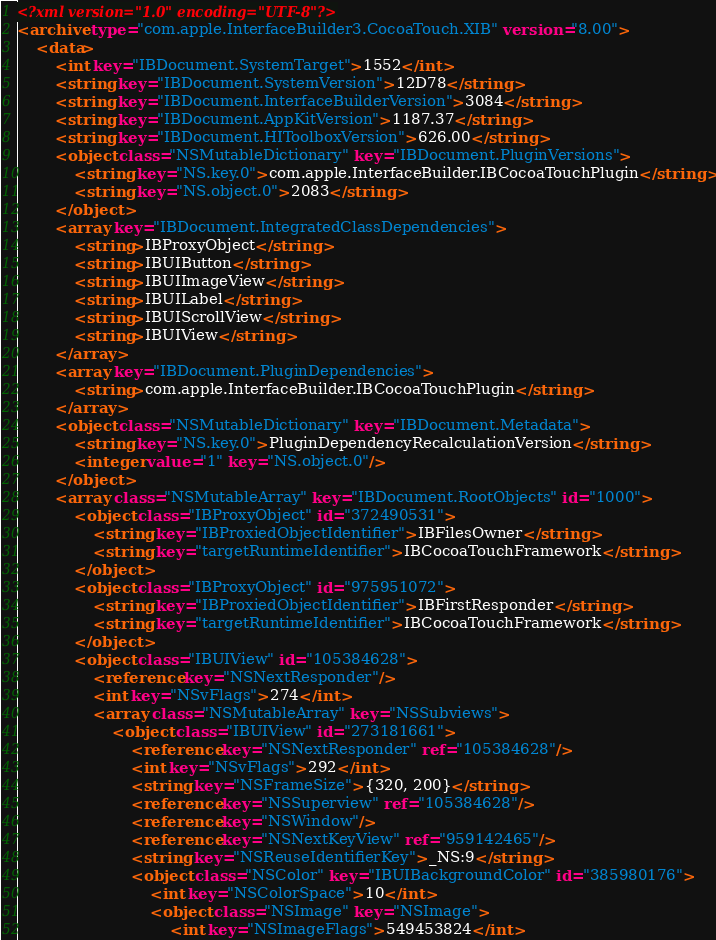Convert code to text. <code><loc_0><loc_0><loc_500><loc_500><_XML_><?xml version="1.0" encoding="UTF-8"?>
<archive type="com.apple.InterfaceBuilder3.CocoaTouch.XIB" version="8.00">
	<data>
		<int key="IBDocument.SystemTarget">1552</int>
		<string key="IBDocument.SystemVersion">12D78</string>
		<string key="IBDocument.InterfaceBuilderVersion">3084</string>
		<string key="IBDocument.AppKitVersion">1187.37</string>
		<string key="IBDocument.HIToolboxVersion">626.00</string>
		<object class="NSMutableDictionary" key="IBDocument.PluginVersions">
			<string key="NS.key.0">com.apple.InterfaceBuilder.IBCocoaTouchPlugin</string>
			<string key="NS.object.0">2083</string>
		</object>
		<array key="IBDocument.IntegratedClassDependencies">
			<string>IBProxyObject</string>
			<string>IBUIButton</string>
			<string>IBUIImageView</string>
			<string>IBUILabel</string>
			<string>IBUIScrollView</string>
			<string>IBUIView</string>
		</array>
		<array key="IBDocument.PluginDependencies">
			<string>com.apple.InterfaceBuilder.IBCocoaTouchPlugin</string>
		</array>
		<object class="NSMutableDictionary" key="IBDocument.Metadata">
			<string key="NS.key.0">PluginDependencyRecalculationVersion</string>
			<integer value="1" key="NS.object.0"/>
		</object>
		<array class="NSMutableArray" key="IBDocument.RootObjects" id="1000">
			<object class="IBProxyObject" id="372490531">
				<string key="IBProxiedObjectIdentifier">IBFilesOwner</string>
				<string key="targetRuntimeIdentifier">IBCocoaTouchFramework</string>
			</object>
			<object class="IBProxyObject" id="975951072">
				<string key="IBProxiedObjectIdentifier">IBFirstResponder</string>
				<string key="targetRuntimeIdentifier">IBCocoaTouchFramework</string>
			</object>
			<object class="IBUIView" id="105384628">
				<reference key="NSNextResponder"/>
				<int key="NSvFlags">274</int>
				<array class="NSMutableArray" key="NSSubviews">
					<object class="IBUIView" id="273181661">
						<reference key="NSNextResponder" ref="105384628"/>
						<int key="NSvFlags">292</int>
						<string key="NSFrameSize">{320, 200}</string>
						<reference key="NSSuperview" ref="105384628"/>
						<reference key="NSWindow"/>
						<reference key="NSNextKeyView" ref="959142465"/>
						<string key="NSReuseIdentifierKey">_NS:9</string>
						<object class="NSColor" key="IBUIBackgroundColor" id="385980176">
							<int key="NSColorSpace">10</int>
							<object class="NSImage" key="NSImage">
								<int key="NSImageFlags">549453824</int></code> 